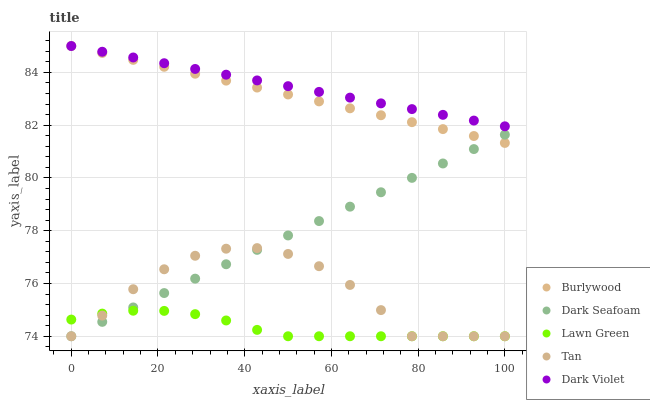Does Lawn Green have the minimum area under the curve?
Answer yes or no. Yes. Does Dark Violet have the maximum area under the curve?
Answer yes or no. Yes. Does Dark Seafoam have the minimum area under the curve?
Answer yes or no. No. Does Dark Seafoam have the maximum area under the curve?
Answer yes or no. No. Is Dark Violet the smoothest?
Answer yes or no. Yes. Is Tan the roughest?
Answer yes or no. Yes. Is Lawn Green the smoothest?
Answer yes or no. No. Is Lawn Green the roughest?
Answer yes or no. No. Does Lawn Green have the lowest value?
Answer yes or no. Yes. Does Dark Violet have the lowest value?
Answer yes or no. No. Does Dark Violet have the highest value?
Answer yes or no. Yes. Does Dark Seafoam have the highest value?
Answer yes or no. No. Is Lawn Green less than Burlywood?
Answer yes or no. Yes. Is Dark Violet greater than Lawn Green?
Answer yes or no. Yes. Does Dark Seafoam intersect Tan?
Answer yes or no. Yes. Is Dark Seafoam less than Tan?
Answer yes or no. No. Is Dark Seafoam greater than Tan?
Answer yes or no. No. Does Lawn Green intersect Burlywood?
Answer yes or no. No. 